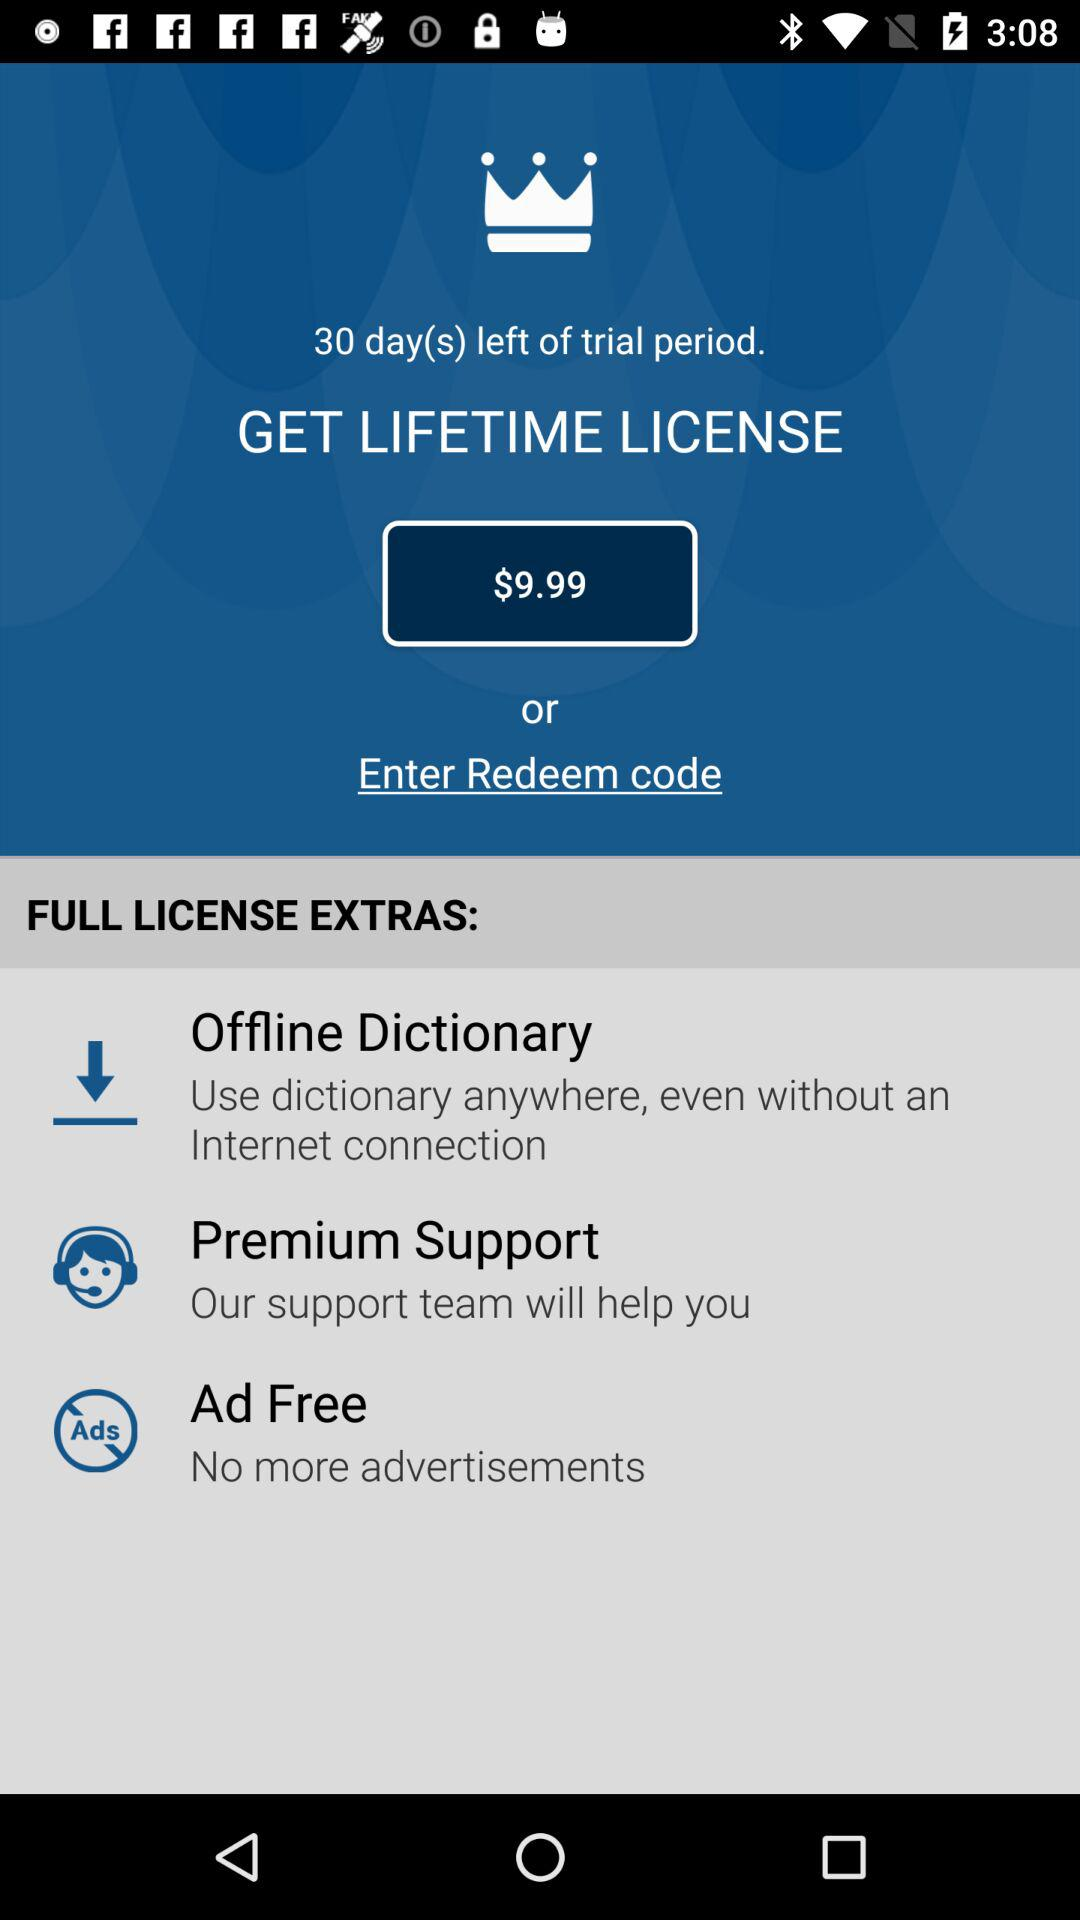How many extra features are included in the lifetime license?
Answer the question using a single word or phrase. 3 